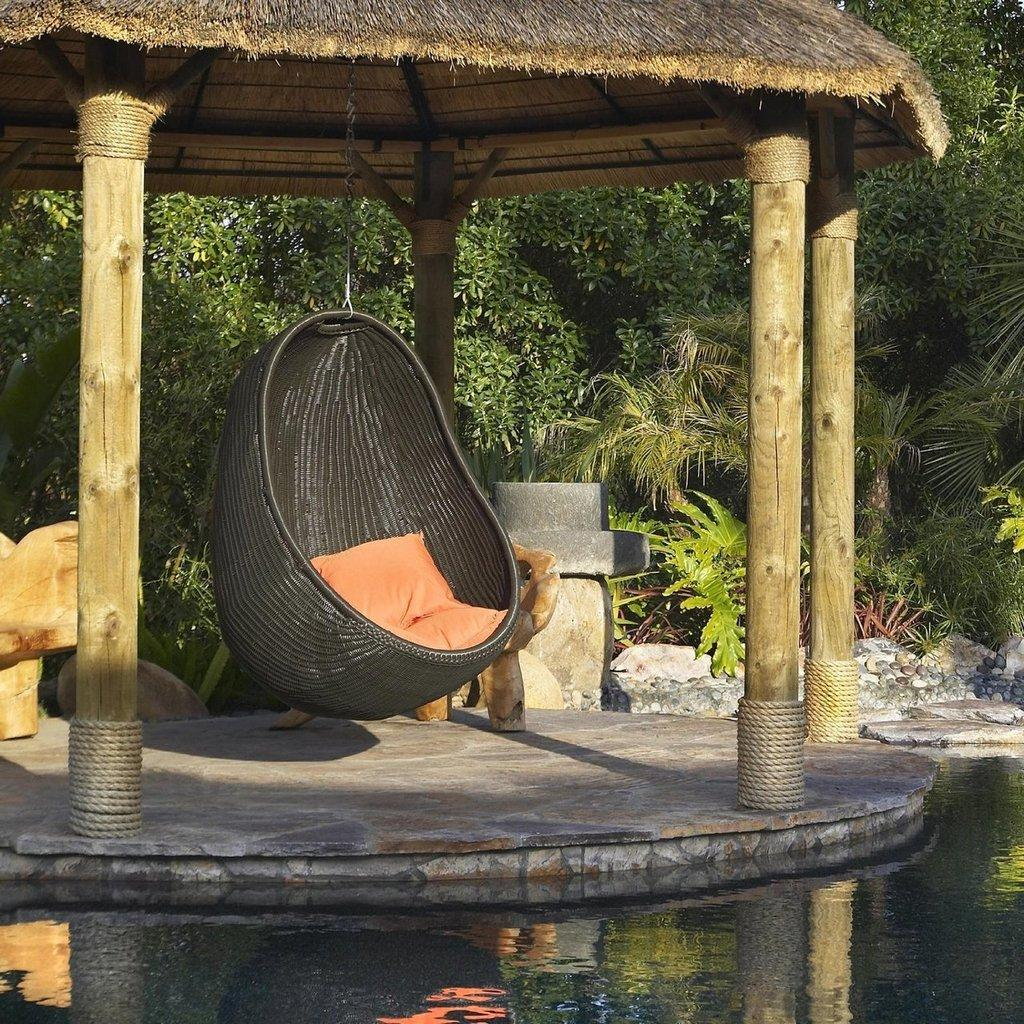What is the main object in the center of the image? There is a swing in the center of the image. How is the swing supported? The swing is hanging from a hut. What can be seen at the bottom of the image? There is water visible at the bottom of the image. What type of natural environment is visible in the background? There are trees and plants in the background of the image. What type of attack can be seen happening in the image? There is no attack present in the image; it features a swing hanging from a hut with water and trees in the background. Can you tell me how many airports are visible in the image? There are no airports present in the image. 